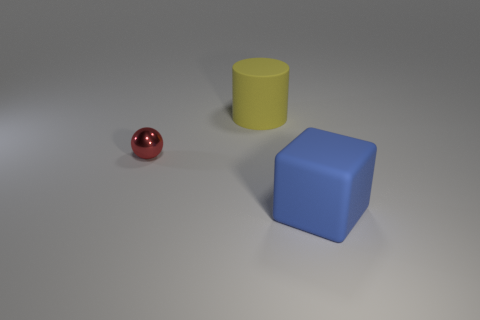Add 2 tiny metal objects. How many objects exist? 5 Add 3 small green matte blocks. How many small green matte blocks exist? 3 Subtract 0 purple cubes. How many objects are left? 3 Subtract all cubes. How many objects are left? 2 Subtract all red blocks. Subtract all cyan cylinders. How many blocks are left? 1 Subtract all yellow balls. How many yellow blocks are left? 0 Subtract all matte cylinders. Subtract all small cyan metal objects. How many objects are left? 2 Add 1 yellow rubber objects. How many yellow rubber objects are left? 2 